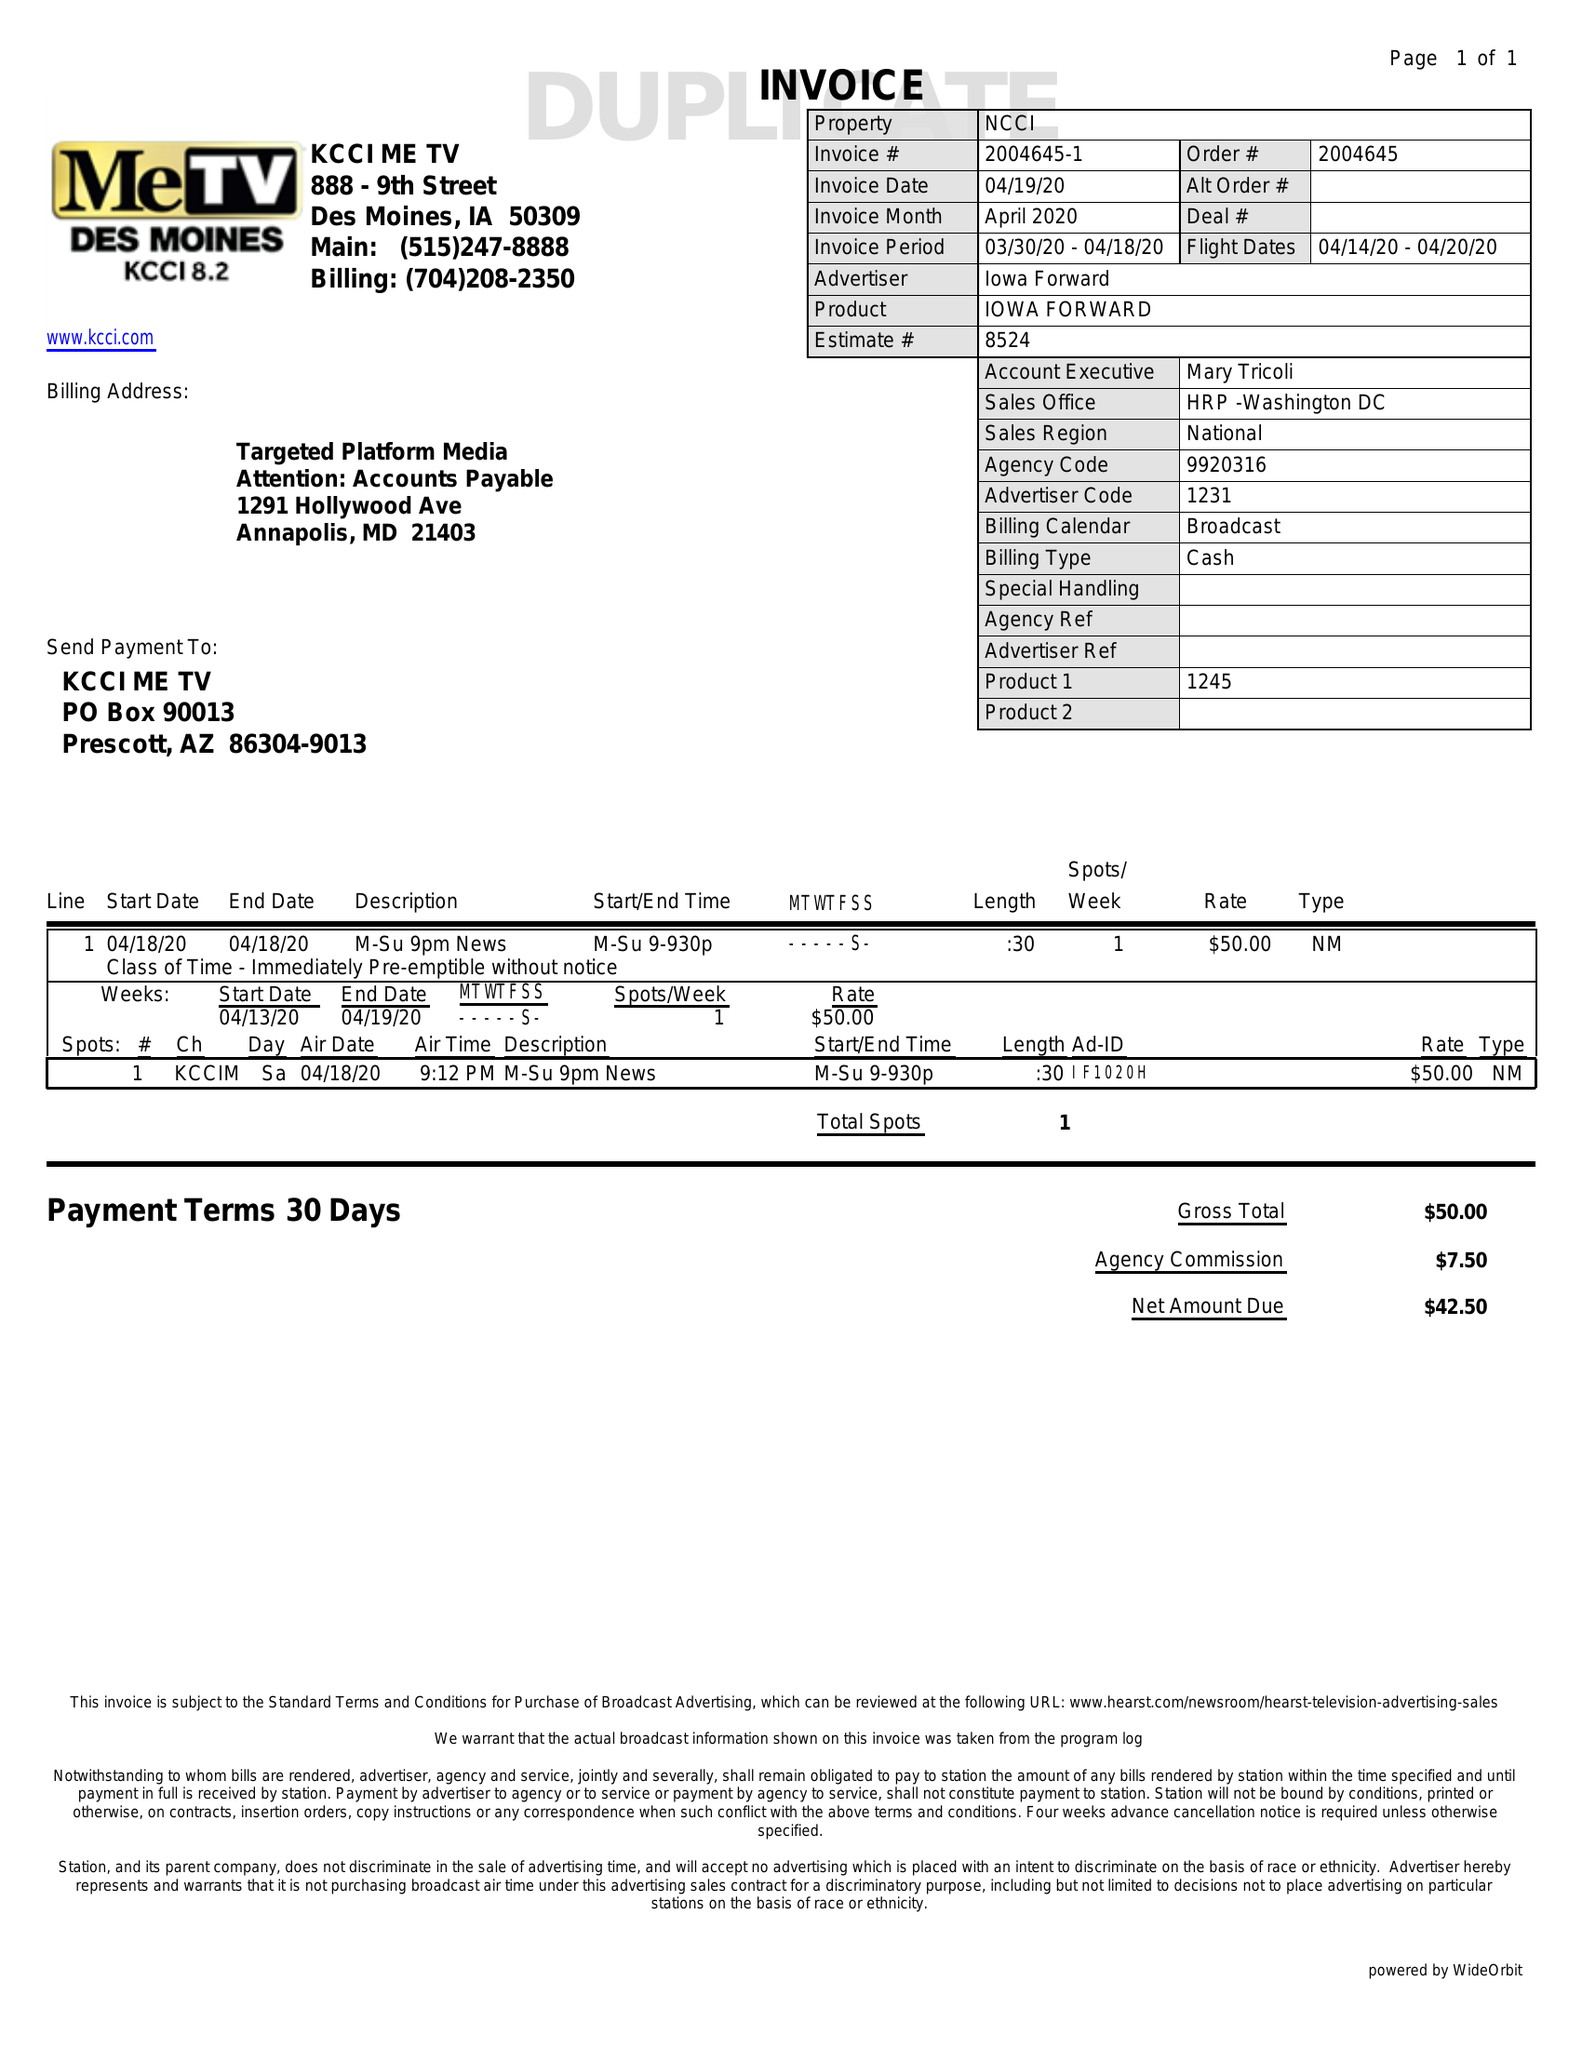What is the value for the flight_to?
Answer the question using a single word or phrase. 04/20/20 